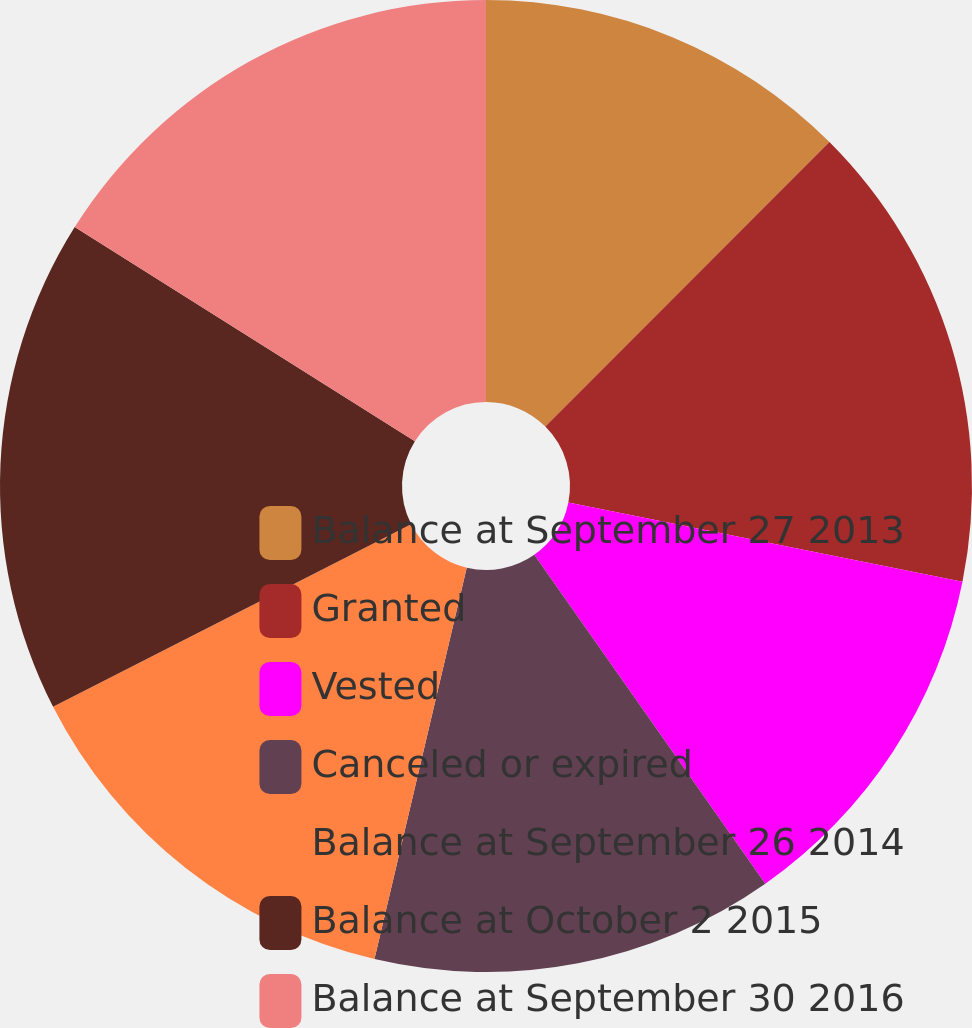<chart> <loc_0><loc_0><loc_500><loc_500><pie_chart><fcel>Balance at September 27 2013<fcel>Granted<fcel>Vested<fcel>Canceled or expired<fcel>Balance at September 26 2014<fcel>Balance at October 2 2015<fcel>Balance at September 30 2016<nl><fcel>12.49%<fcel>15.67%<fcel>12.1%<fcel>13.43%<fcel>13.81%<fcel>16.45%<fcel>16.06%<nl></chart> 